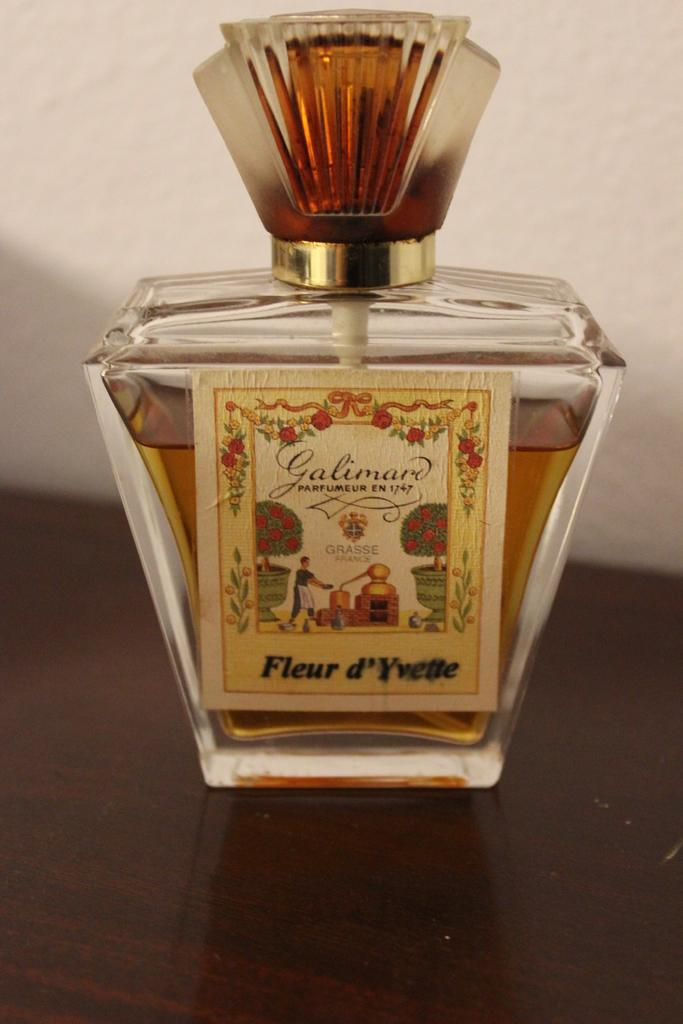<image>
Summarize the visual content of the image. A bottle of Fluer d'Yvelle perfume is nearly full. 